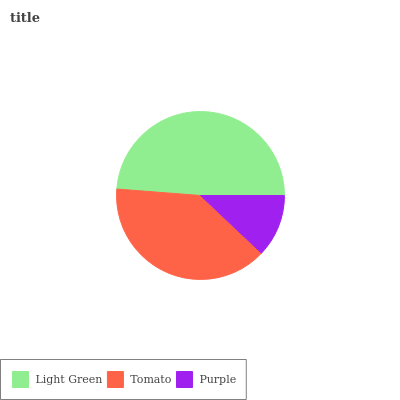Is Purple the minimum?
Answer yes or no. Yes. Is Light Green the maximum?
Answer yes or no. Yes. Is Tomato the minimum?
Answer yes or no. No. Is Tomato the maximum?
Answer yes or no. No. Is Light Green greater than Tomato?
Answer yes or no. Yes. Is Tomato less than Light Green?
Answer yes or no. Yes. Is Tomato greater than Light Green?
Answer yes or no. No. Is Light Green less than Tomato?
Answer yes or no. No. Is Tomato the high median?
Answer yes or no. Yes. Is Tomato the low median?
Answer yes or no. Yes. Is Light Green the high median?
Answer yes or no. No. Is Light Green the low median?
Answer yes or no. No. 